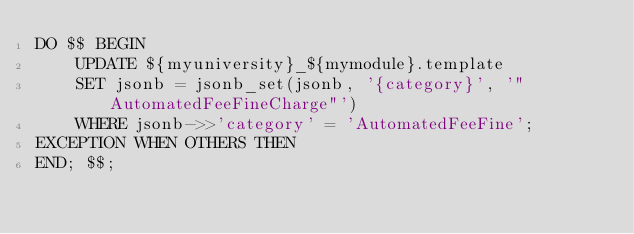<code> <loc_0><loc_0><loc_500><loc_500><_SQL_>DO $$ BEGIN
    UPDATE ${myuniversity}_${mymodule}.template
    SET jsonb = jsonb_set(jsonb, '{category}', '"AutomatedFeeFineCharge"')
    WHERE jsonb->>'category' = 'AutomatedFeeFine';
EXCEPTION WHEN OTHERS THEN
END; $$;</code> 